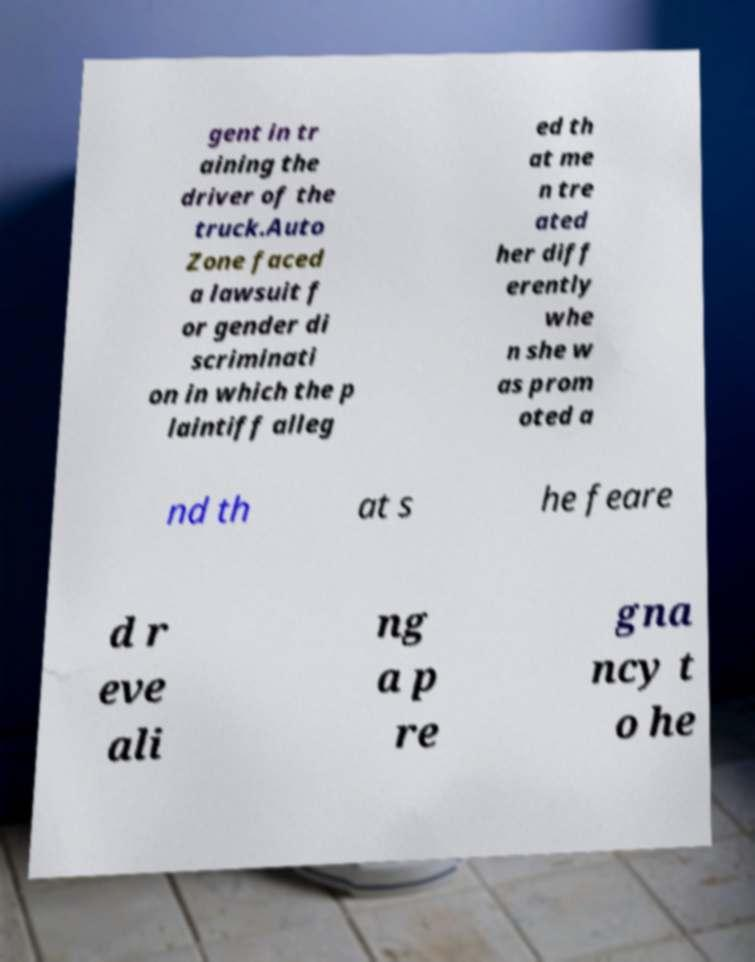For documentation purposes, I need the text within this image transcribed. Could you provide that? gent in tr aining the driver of the truck.Auto Zone faced a lawsuit f or gender di scriminati on in which the p laintiff alleg ed th at me n tre ated her diff erently whe n she w as prom oted a nd th at s he feare d r eve ali ng a p re gna ncy t o he 